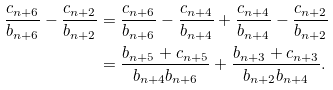<formula> <loc_0><loc_0><loc_500><loc_500>\frac { c _ { n + 6 } } { b _ { n + 6 } } - \frac { c _ { n + 2 } } { b _ { n + 2 } } & = \frac { c _ { n + 6 } } { b _ { n + 6 } } - \frac { c _ { n + 4 } } { b _ { n + 4 } } + \frac { c _ { n + 4 } } { b _ { n + 4 } } - \frac { c _ { n + 2 } } { b _ { n + 2 } } \\ & = \frac { b _ { n + 5 } + c _ { n + 5 } } { b _ { n + 4 } b _ { n + 6 } } + \frac { b _ { n + 3 } + c _ { n + 3 } } { b _ { n + 2 } b _ { n + 4 } } .</formula> 